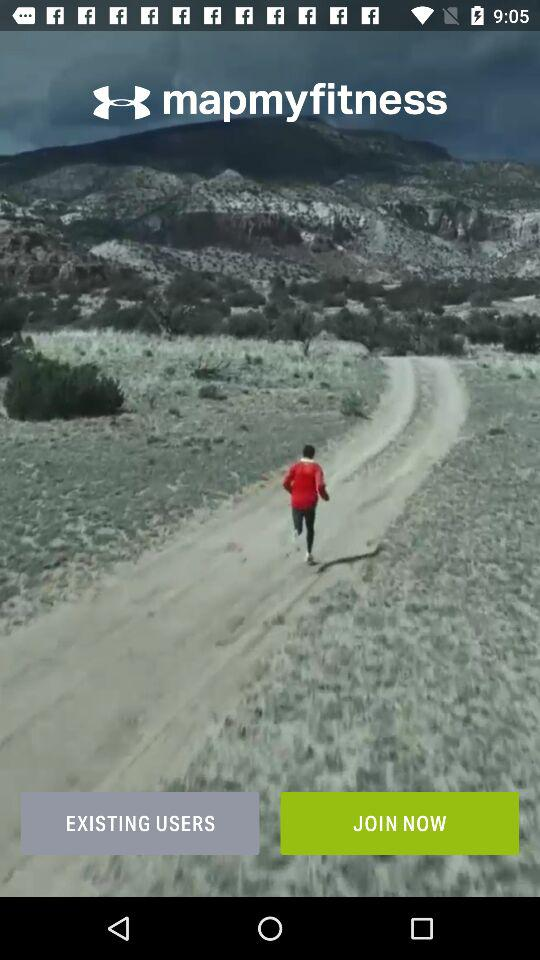What is the application name? The application name is "mapmyfitness". 